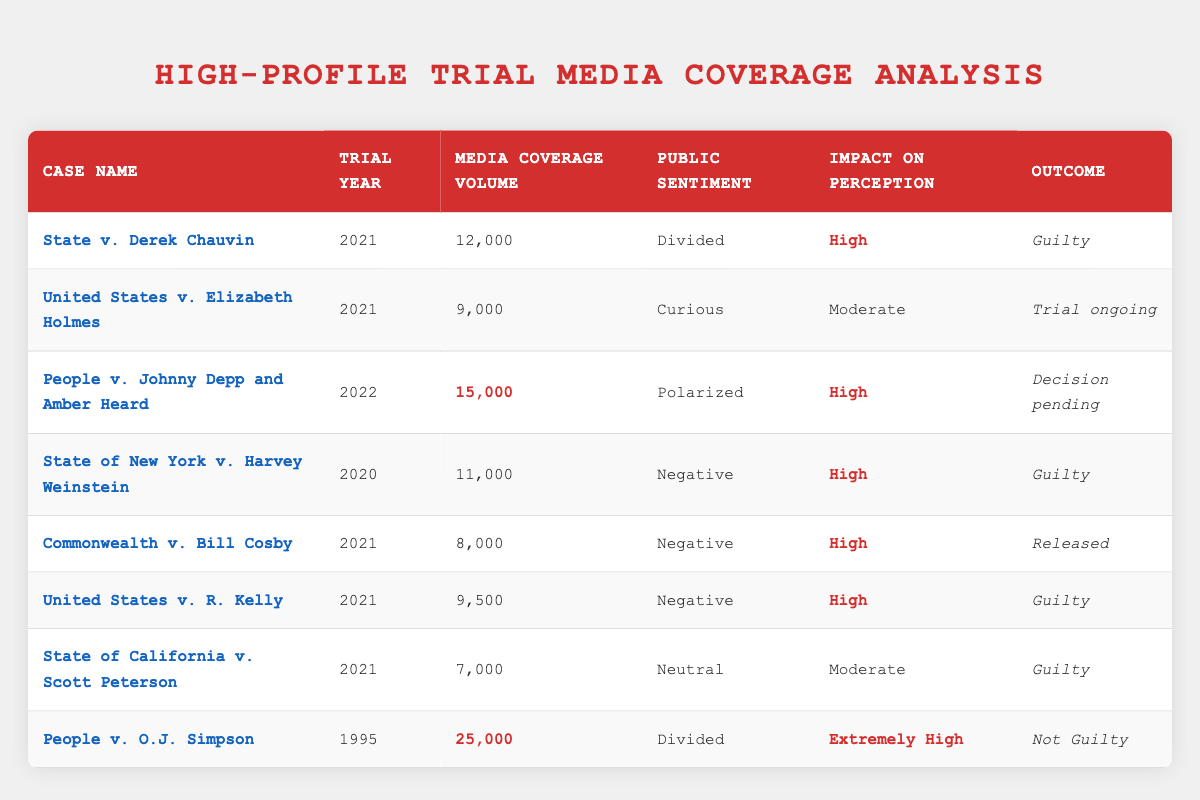What is the media coverage volume for the trial "State v. Derek Chauvin"? The table shows that the media coverage volume for the case "State v. Derek Chauvin" is listed as 12,000.
Answer: 12,000 How many trials had a high impact on public perception? In the table, I can identify the trials with a "High" impact on perception: "State v. Derek Chauvin," "State of New York v. Harvey Weinstein," "Commonwealth v. Bill Cosby," "United States v. R. Kelly," and "People v. Johnny Depp and Amber Heard." This gives a total of 5 trials.
Answer: 5 Which trial had the highest media coverage volume? The entry for "People v. O.J. Simpson" shows a media coverage volume of 25,000, which is the highest in the table compared to all other trials.
Answer: People v. O.J. Simpson What was the public sentiment for the trial with the outcome "Guilty"? Looking at the trials with a "Guilty" outcome, I find three trials: "State v. Derek Chauvin" (Divided), "State of New York v. Harvey Weinstein" (Negative), and "United States v. R. Kelly" (Negative). The public sentiments are divided between these, but "Negative" sentiment is noted twice.
Answer: Divided and Negative If you average the media coverage volumes of all trials, what do you get? Summing the media coverage volumes gives: 12,000 + 9,000 + 15,000 + 11,000 + 8,000 + 9,500 + 7,000 + 25,000 = 96,500. There are 8 trials, so the average is 96,500 / 8 = 12,062.5.
Answer: 12,062.5 Is it true that all trials with high impact on perception also had guilty outcomes? Reviewing the trials, "People v. Johnny Depp and Amber Heard" has a high impact on perception but the outcome is "Decision pending." Thus, the statement is not true.
Answer: No What are the trial outcomes for cases that had negative public sentiment? The trials with negative public sentiment are "State of New York v. Harvey Weinstein" (Guilty), "Commonwealth v. Bill Cosby" (Released), and "United States v. R. Kelly" (Guilty). The outcomes include one guilty and one released, leading to two guilty.
Answer: Guilty and Released How does the media coverage volume relate to public sentiment in the case "People v. Johnny Depp and Amber Heard"? The media coverage volume of "People v. Johnny Depp and Amber Heard" is 15,000 with public sentiment labeled as "Polarized." This indicates that while the coverage is high, the public sentiment is highly divided, showing a complex relationship between high media volume and divided opinion.
Answer: High media volume and polarized sentiment 